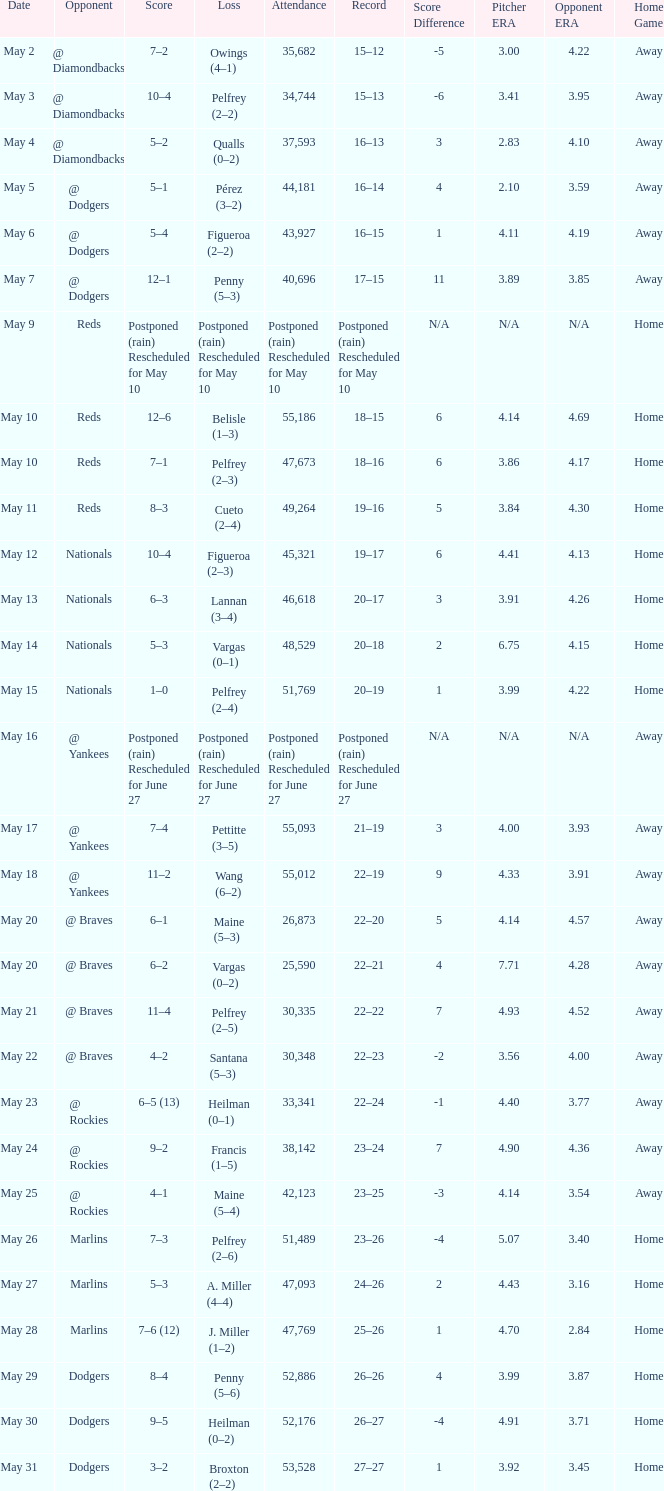Record of 22–20 involved what score? 6–1. 